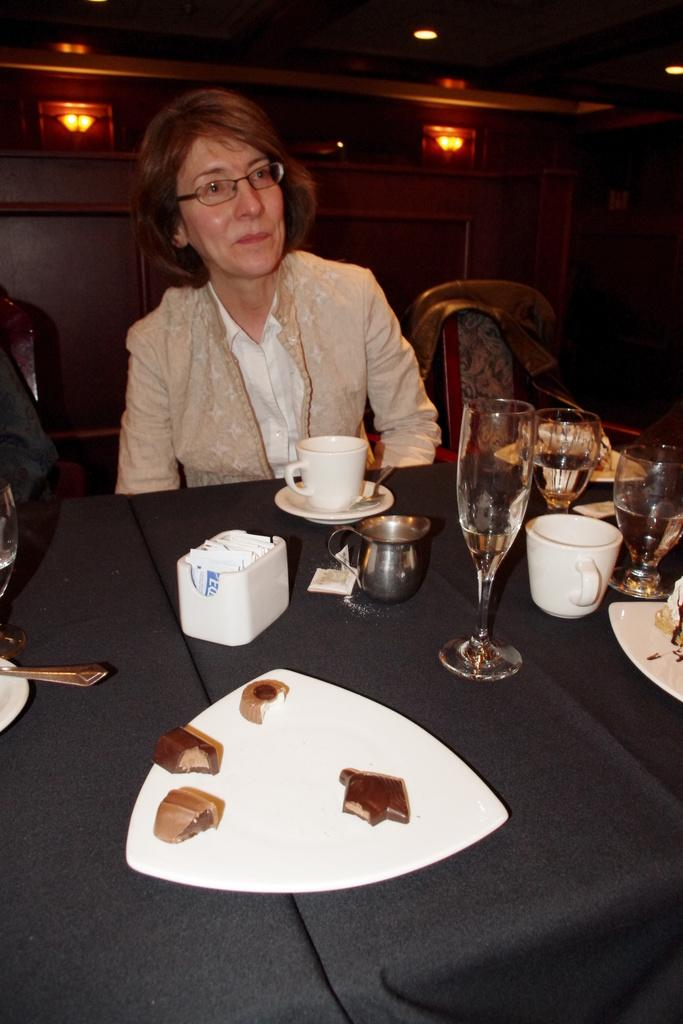What is the woman doing in the image? The woman is sitting in front of a table. What objects can be seen on the table? There are cups, glasses, and plates on the table. How many teeth can be seen in the woman's mouth in the image? There is no information about the woman's teeth in the image, so we cannot determine the number of teeth visible. 